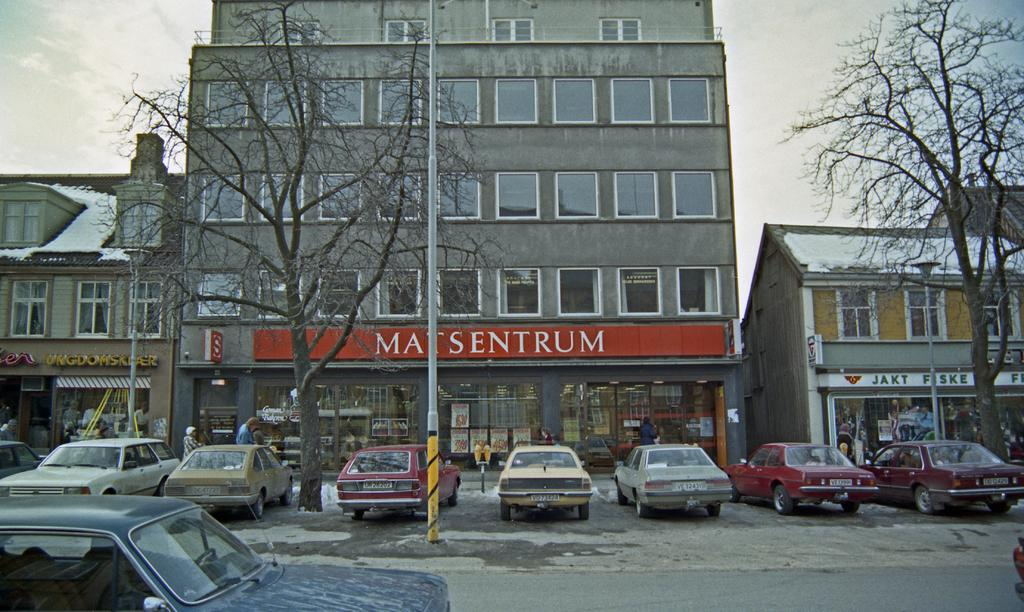Where was the image taken? The image was clicked outside. What can be seen in the middle of the image? There are buildings and trees in the middle of the image. What is visible at the bottom of the image? There are cars at the bottom of the image. What is visible at the top of the image? The sky is visible at the top of the image. Can you hear the hen coughing in the image? There is no hen or any sound in the image, as it is a still photograph. 